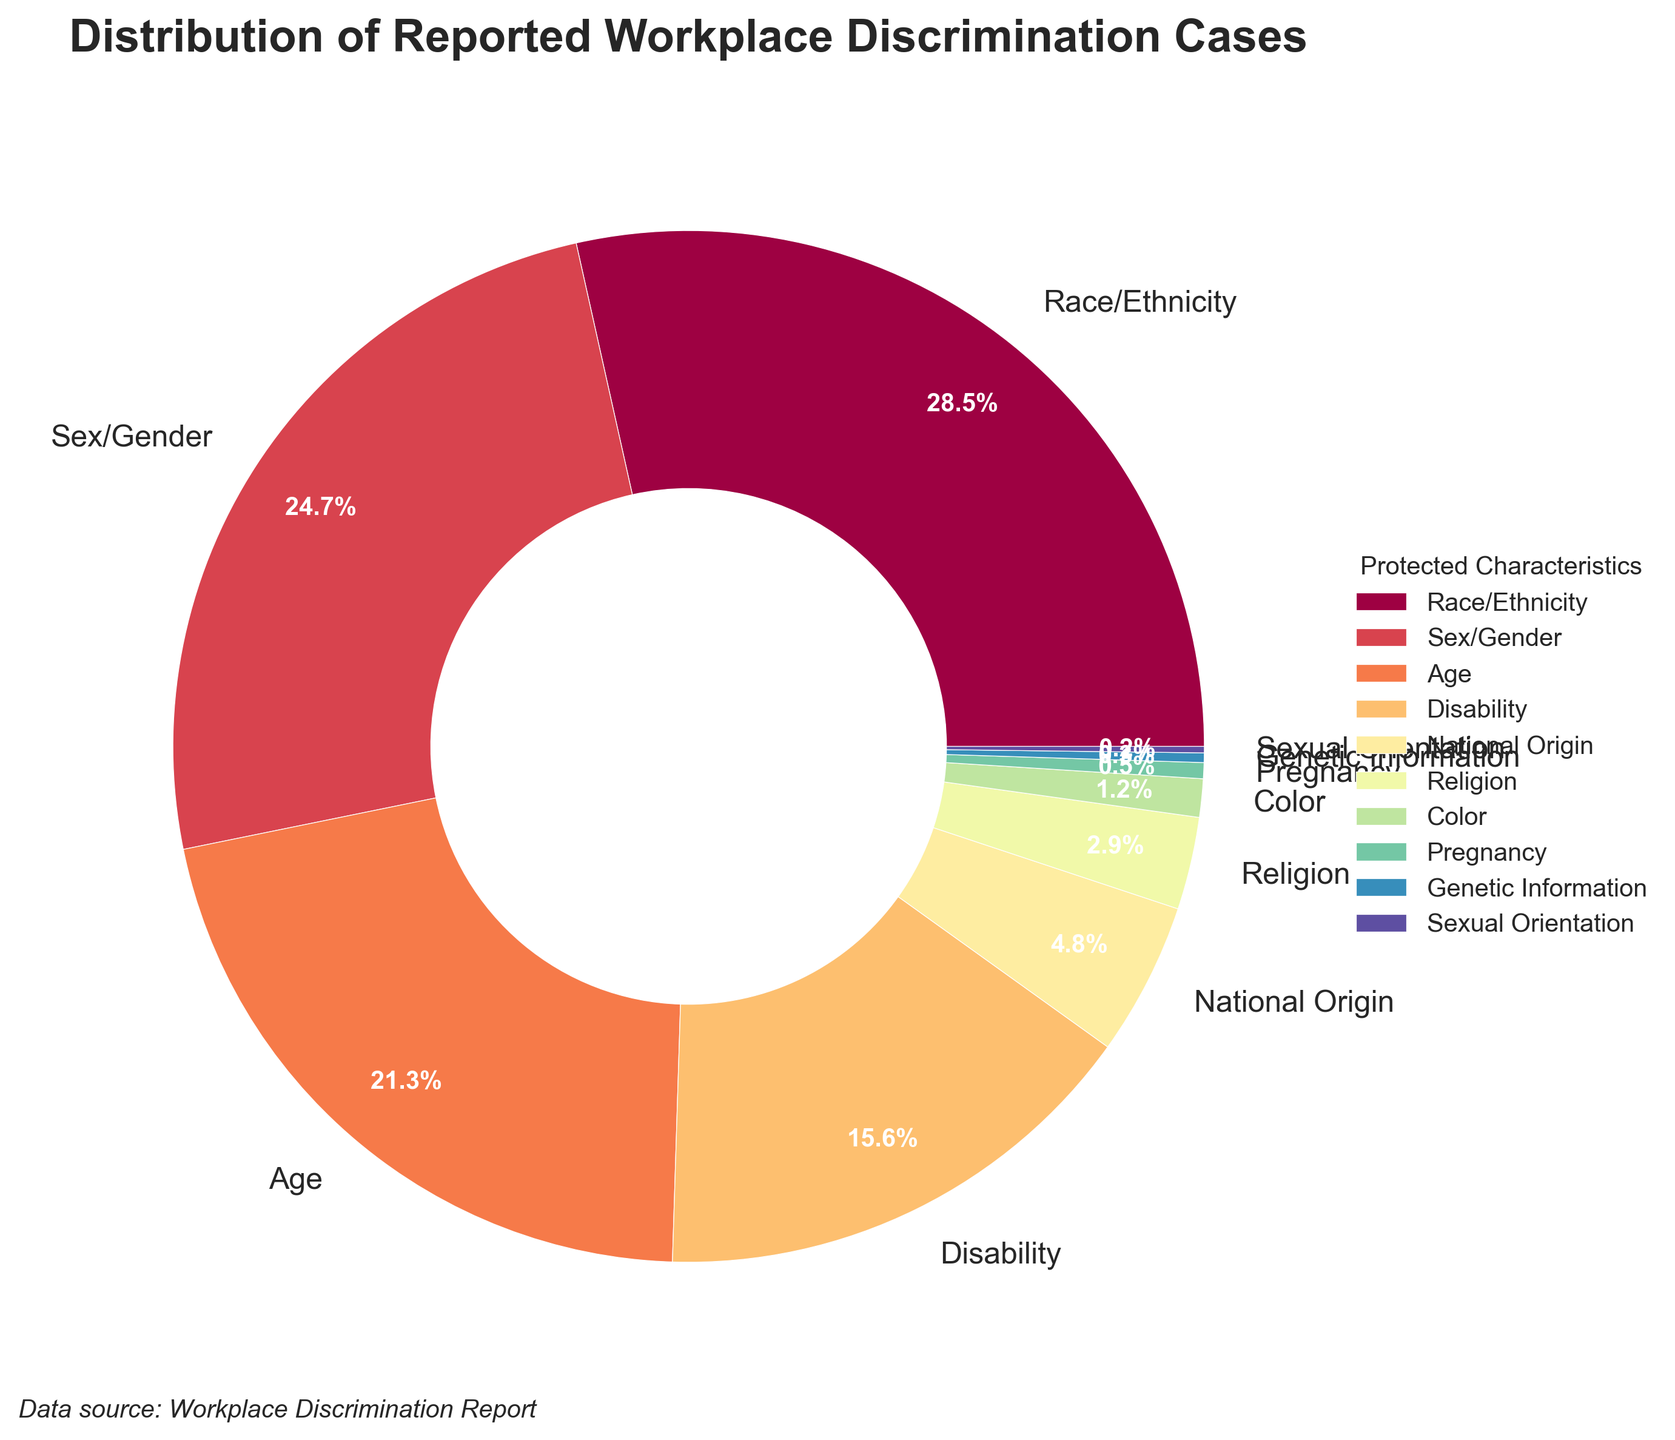Which protected characteristic has the highest percentage of reported workplace discrimination cases? From the figure, we can see that the largest slice of the pie chart, labeled "Race/Ethnicity" with 28.5%, represents the highest percentage of reported workplace discrimination cases.
Answer: Race/Ethnicity What is the combined percentage of reported discrimination cases based on Race/Ethnicity and Sex/Gender? Adding the percentages for Race/Ethnicity (28.5%) and Sex/Gender (24.7%) gives us the combined percentage: 28.5 + 24.7 = 53.2%.
Answer: 53.2% Which three protected characteristics have the lowest percentages of reported workplace discrimination cases? The smallest slices of the pie chart are labeled "Genetic Information" (0.3%), "Sexual Orientation" (0.2%), and "Pregnancy" (0.5%), which are the three characteristics with the lowest percentages.
Answer: Genetic Information, Sexual Orientation, Pregnancy How much greater is the percentage of reported discrimination cases for Age compared to National Origin? The percentage for Age is 21.3%, and for National Origin, it is 4.8%. The difference between them is calculated as 21.3 - 4.8 = 16.5%.
Answer: 16.5% Is the percentage of reported discrimination cases for Disability greater than that for Age? The figure shows that Disability has a percentage of 15.6%, while Age has 21.3%. Since 15.6% is less than 21.3%, the percentage for Disability is not greater.
Answer: No What percentage of reported discrimination cases are based on characteristics other than Race/Ethnicity and Sex/Gender? Subtracting the combined percentage of Race/Ethnicity (28.5%) and Sex/Gender (24.7%) from 100% gives us: 100 - (28.5 + 24.7) = 46.8%.
Answer: 46.8% Which protected characteristic has a percentage closest to the average percentage of all reported workplace discrimination cases? First, calculate the average percentage by summing all percentages and dividing by the number of characteristics: (28.5 + 24.7 + 21.3 + 15.6 + 4.8 + 2.9 + 1.2 + 0.5 + 0.3 + 0.2) / 10 = 10%. The characteristic whose percentage (15.6% for Disability) is closest to this average (10%) is Disability.
Answer: Disability Describe the color and position of the Religion section in the pie chart. The Religion section is labeled "Religion" and has a percentage of 2.9%. It is typically positioned to the left-middle of the pie chart and colored in a distinct segment of the color spectrum, typically falling between two other segments like National Origin (4.8%) and Color (1.2%).
Answer: Left-middle and distinct segment color If you combine all the categories with percentages less than 5%, what fraction of the pie chart would they represent? Adding the percentages of National Origin (4.8%), Religion (2.9%), Color (1.2%), Pregnancy (0.5%), Genetic Information (0.3%), and Sexual Orientation (0.2%) gives us: 4.8 + 2.9 + 1.2 + 0.5 + 0.3 + 0.2 = 9.9%. To represent this as a fraction of the pie chart, it is 9.9/100, which simplifies to approximately 1/10.
Answer: 1/10 Is the percentage for Sex/Gender discrimination closer to the percentage for Race/Ethnicity or Age discrimination? Comparing the distances, Sex/Gender (24.7%) from Race/Ethnicity (28.5%): 28.5 - 24.7 = 3.8%. From Age (21.3%): 24.7 - 21.3 = 3.4%. Since 3.4 is less than 3.8, the percentage for Sex/Gender discrimination is closer to Age discrimination.
Answer: Age 